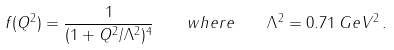Convert formula to latex. <formula><loc_0><loc_0><loc_500><loc_500>f ( Q ^ { 2 } ) = \frac { 1 } { ( 1 + Q ^ { 2 } / \Lambda ^ { 2 } ) ^ { 4 } } \quad w h e r e \quad \Lambda ^ { 2 } = 0 . 7 1 \, G e V ^ { 2 } \, .</formula> 